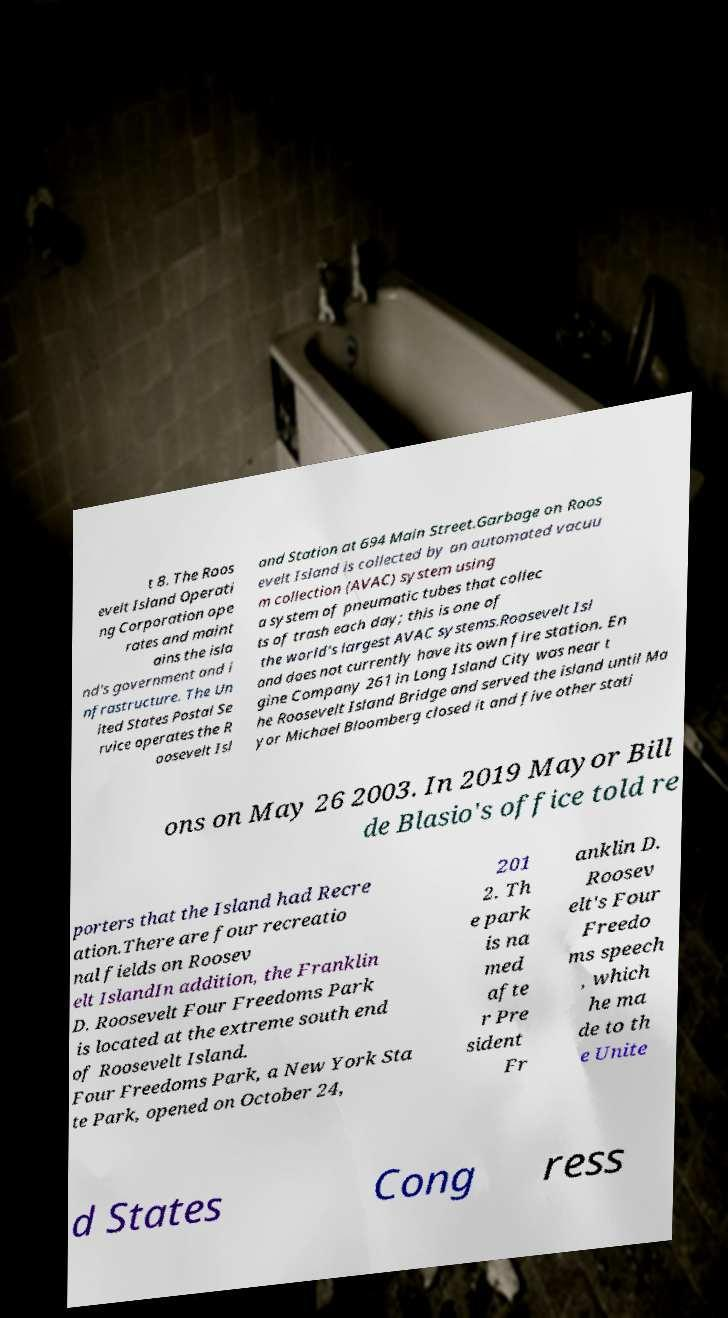Please read and relay the text visible in this image. What does it say? t 8. The Roos evelt Island Operati ng Corporation ope rates and maint ains the isla nd's government and i nfrastructure. The Un ited States Postal Se rvice operates the R oosevelt Isl and Station at 694 Main Street.Garbage on Roos evelt Island is collected by an automated vacuu m collection (AVAC) system using a system of pneumatic tubes that collec ts of trash each day; this is one of the world's largest AVAC systems.Roosevelt Isl and does not currently have its own fire station. En gine Company 261 in Long Island City was near t he Roosevelt Island Bridge and served the island until Ma yor Michael Bloomberg closed it and five other stati ons on May 26 2003. In 2019 Mayor Bill de Blasio's office told re porters that the Island had Recre ation.There are four recreatio nal fields on Roosev elt IslandIn addition, the Franklin D. Roosevelt Four Freedoms Park is located at the extreme south end of Roosevelt Island. Four Freedoms Park, a New York Sta te Park, opened on October 24, 201 2. Th e park is na med afte r Pre sident Fr anklin D. Roosev elt's Four Freedo ms speech , which he ma de to th e Unite d States Cong ress 